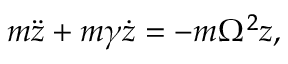<formula> <loc_0><loc_0><loc_500><loc_500>m \ddot { z } + m \gamma \dot { z } = - m \Omega ^ { 2 } z ,</formula> 